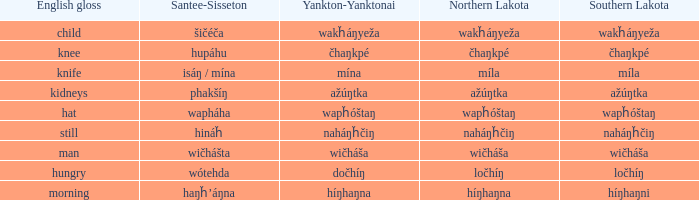Name the southern lakota for híŋhaŋna Híŋhaŋni. 